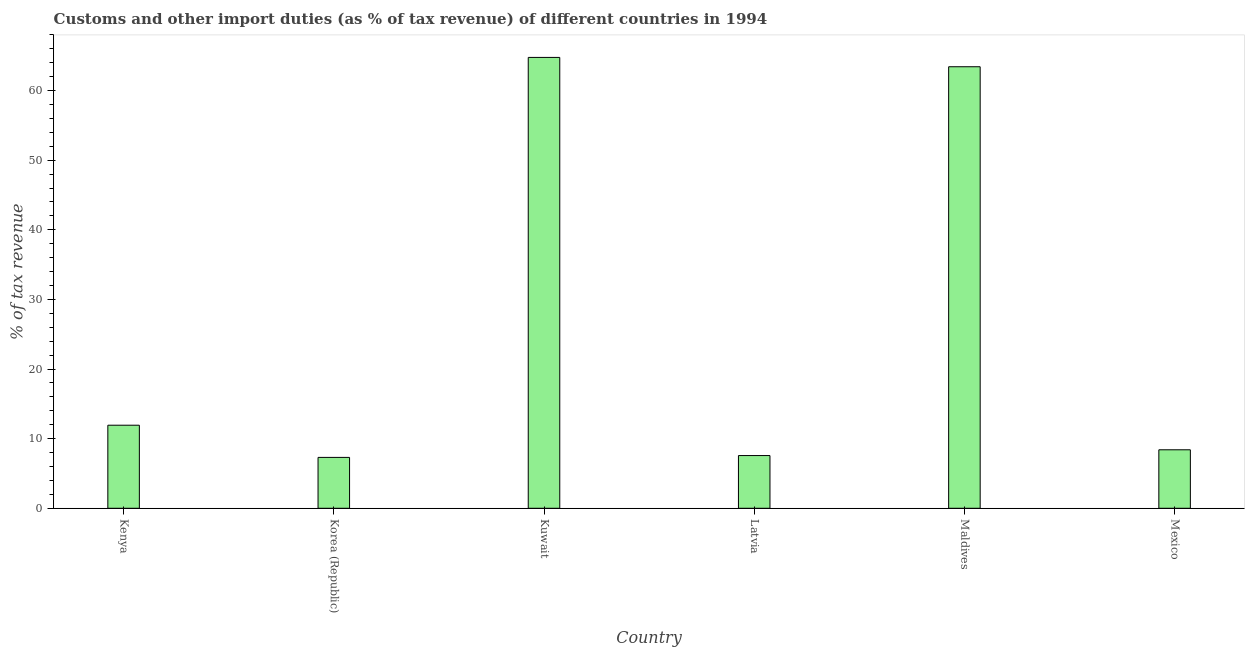Does the graph contain any zero values?
Your response must be concise. No. What is the title of the graph?
Give a very brief answer. Customs and other import duties (as % of tax revenue) of different countries in 1994. What is the label or title of the Y-axis?
Provide a short and direct response. % of tax revenue. What is the customs and other import duties in Latvia?
Your answer should be very brief. 7.57. Across all countries, what is the maximum customs and other import duties?
Your response must be concise. 64.76. Across all countries, what is the minimum customs and other import duties?
Offer a very short reply. 7.31. In which country was the customs and other import duties maximum?
Provide a succinct answer. Kuwait. In which country was the customs and other import duties minimum?
Provide a short and direct response. Korea (Republic). What is the sum of the customs and other import duties?
Make the answer very short. 163.39. What is the difference between the customs and other import duties in Korea (Republic) and Kuwait?
Provide a succinct answer. -57.46. What is the average customs and other import duties per country?
Keep it short and to the point. 27.23. What is the median customs and other import duties?
Your response must be concise. 10.17. What is the ratio of the customs and other import duties in Kenya to that in Latvia?
Keep it short and to the point. 1.58. Is the difference between the customs and other import duties in Kenya and Korea (Republic) greater than the difference between any two countries?
Your response must be concise. No. What is the difference between the highest and the second highest customs and other import duties?
Keep it short and to the point. 1.34. Is the sum of the customs and other import duties in Korea (Republic) and Latvia greater than the maximum customs and other import duties across all countries?
Your answer should be very brief. No. What is the difference between the highest and the lowest customs and other import duties?
Keep it short and to the point. 57.46. In how many countries, is the customs and other import duties greater than the average customs and other import duties taken over all countries?
Keep it short and to the point. 2. Are all the bars in the graph horizontal?
Provide a succinct answer. No. What is the difference between two consecutive major ticks on the Y-axis?
Keep it short and to the point. 10. Are the values on the major ticks of Y-axis written in scientific E-notation?
Offer a terse response. No. What is the % of tax revenue in Kenya?
Ensure brevity in your answer.  11.93. What is the % of tax revenue in Korea (Republic)?
Your response must be concise. 7.31. What is the % of tax revenue of Kuwait?
Your response must be concise. 64.76. What is the % of tax revenue of Latvia?
Make the answer very short. 7.57. What is the % of tax revenue of Maldives?
Keep it short and to the point. 63.42. What is the % of tax revenue in Mexico?
Ensure brevity in your answer.  8.4. What is the difference between the % of tax revenue in Kenya and Korea (Republic)?
Your answer should be very brief. 4.62. What is the difference between the % of tax revenue in Kenya and Kuwait?
Offer a terse response. -52.83. What is the difference between the % of tax revenue in Kenya and Latvia?
Make the answer very short. 4.36. What is the difference between the % of tax revenue in Kenya and Maldives?
Offer a very short reply. -51.49. What is the difference between the % of tax revenue in Kenya and Mexico?
Give a very brief answer. 3.53. What is the difference between the % of tax revenue in Korea (Republic) and Kuwait?
Your answer should be very brief. -57.46. What is the difference between the % of tax revenue in Korea (Republic) and Latvia?
Provide a short and direct response. -0.26. What is the difference between the % of tax revenue in Korea (Republic) and Maldives?
Give a very brief answer. -56.12. What is the difference between the % of tax revenue in Korea (Republic) and Mexico?
Your answer should be compact. -1.09. What is the difference between the % of tax revenue in Kuwait and Latvia?
Your answer should be very brief. 57.19. What is the difference between the % of tax revenue in Kuwait and Maldives?
Provide a succinct answer. 1.34. What is the difference between the % of tax revenue in Kuwait and Mexico?
Keep it short and to the point. 56.36. What is the difference between the % of tax revenue in Latvia and Maldives?
Offer a terse response. -55.85. What is the difference between the % of tax revenue in Latvia and Mexico?
Offer a very short reply. -0.83. What is the difference between the % of tax revenue in Maldives and Mexico?
Your answer should be very brief. 55.02. What is the ratio of the % of tax revenue in Kenya to that in Korea (Republic)?
Your answer should be compact. 1.63. What is the ratio of the % of tax revenue in Kenya to that in Kuwait?
Your answer should be compact. 0.18. What is the ratio of the % of tax revenue in Kenya to that in Latvia?
Provide a short and direct response. 1.58. What is the ratio of the % of tax revenue in Kenya to that in Maldives?
Give a very brief answer. 0.19. What is the ratio of the % of tax revenue in Kenya to that in Mexico?
Provide a short and direct response. 1.42. What is the ratio of the % of tax revenue in Korea (Republic) to that in Kuwait?
Your answer should be compact. 0.11. What is the ratio of the % of tax revenue in Korea (Republic) to that in Latvia?
Provide a short and direct response. 0.96. What is the ratio of the % of tax revenue in Korea (Republic) to that in Maldives?
Offer a very short reply. 0.12. What is the ratio of the % of tax revenue in Korea (Republic) to that in Mexico?
Keep it short and to the point. 0.87. What is the ratio of the % of tax revenue in Kuwait to that in Latvia?
Offer a terse response. 8.55. What is the ratio of the % of tax revenue in Kuwait to that in Maldives?
Your answer should be compact. 1.02. What is the ratio of the % of tax revenue in Kuwait to that in Mexico?
Give a very brief answer. 7.71. What is the ratio of the % of tax revenue in Latvia to that in Maldives?
Offer a very short reply. 0.12. What is the ratio of the % of tax revenue in Latvia to that in Mexico?
Give a very brief answer. 0.9. What is the ratio of the % of tax revenue in Maldives to that in Mexico?
Provide a succinct answer. 7.55. 